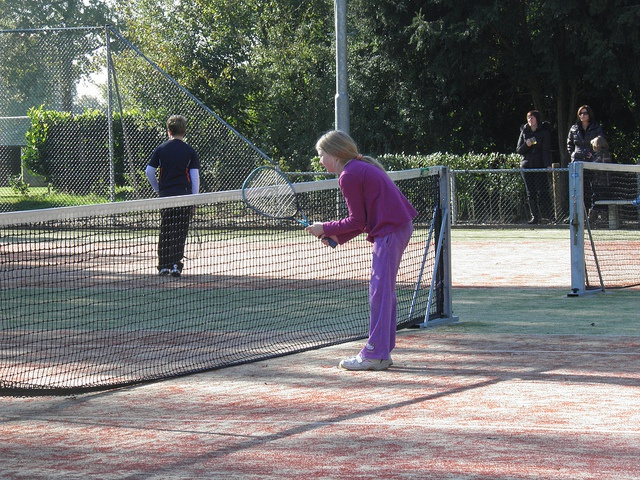Describe the objects in this image and their specific colors. I can see people in gray and purple tones, people in gray, black, and darkgray tones, people in gray, black, darkgray, and brown tones, tennis racket in gray, darkgray, lightgray, and black tones, and people in gray, black, and darkgray tones in this image. 